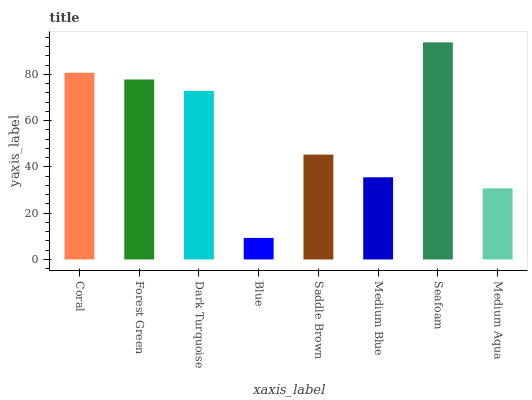Is Blue the minimum?
Answer yes or no. Yes. Is Seafoam the maximum?
Answer yes or no. Yes. Is Forest Green the minimum?
Answer yes or no. No. Is Forest Green the maximum?
Answer yes or no. No. Is Coral greater than Forest Green?
Answer yes or no. Yes. Is Forest Green less than Coral?
Answer yes or no. Yes. Is Forest Green greater than Coral?
Answer yes or no. No. Is Coral less than Forest Green?
Answer yes or no. No. Is Dark Turquoise the high median?
Answer yes or no. Yes. Is Saddle Brown the low median?
Answer yes or no. Yes. Is Coral the high median?
Answer yes or no. No. Is Medium Aqua the low median?
Answer yes or no. No. 